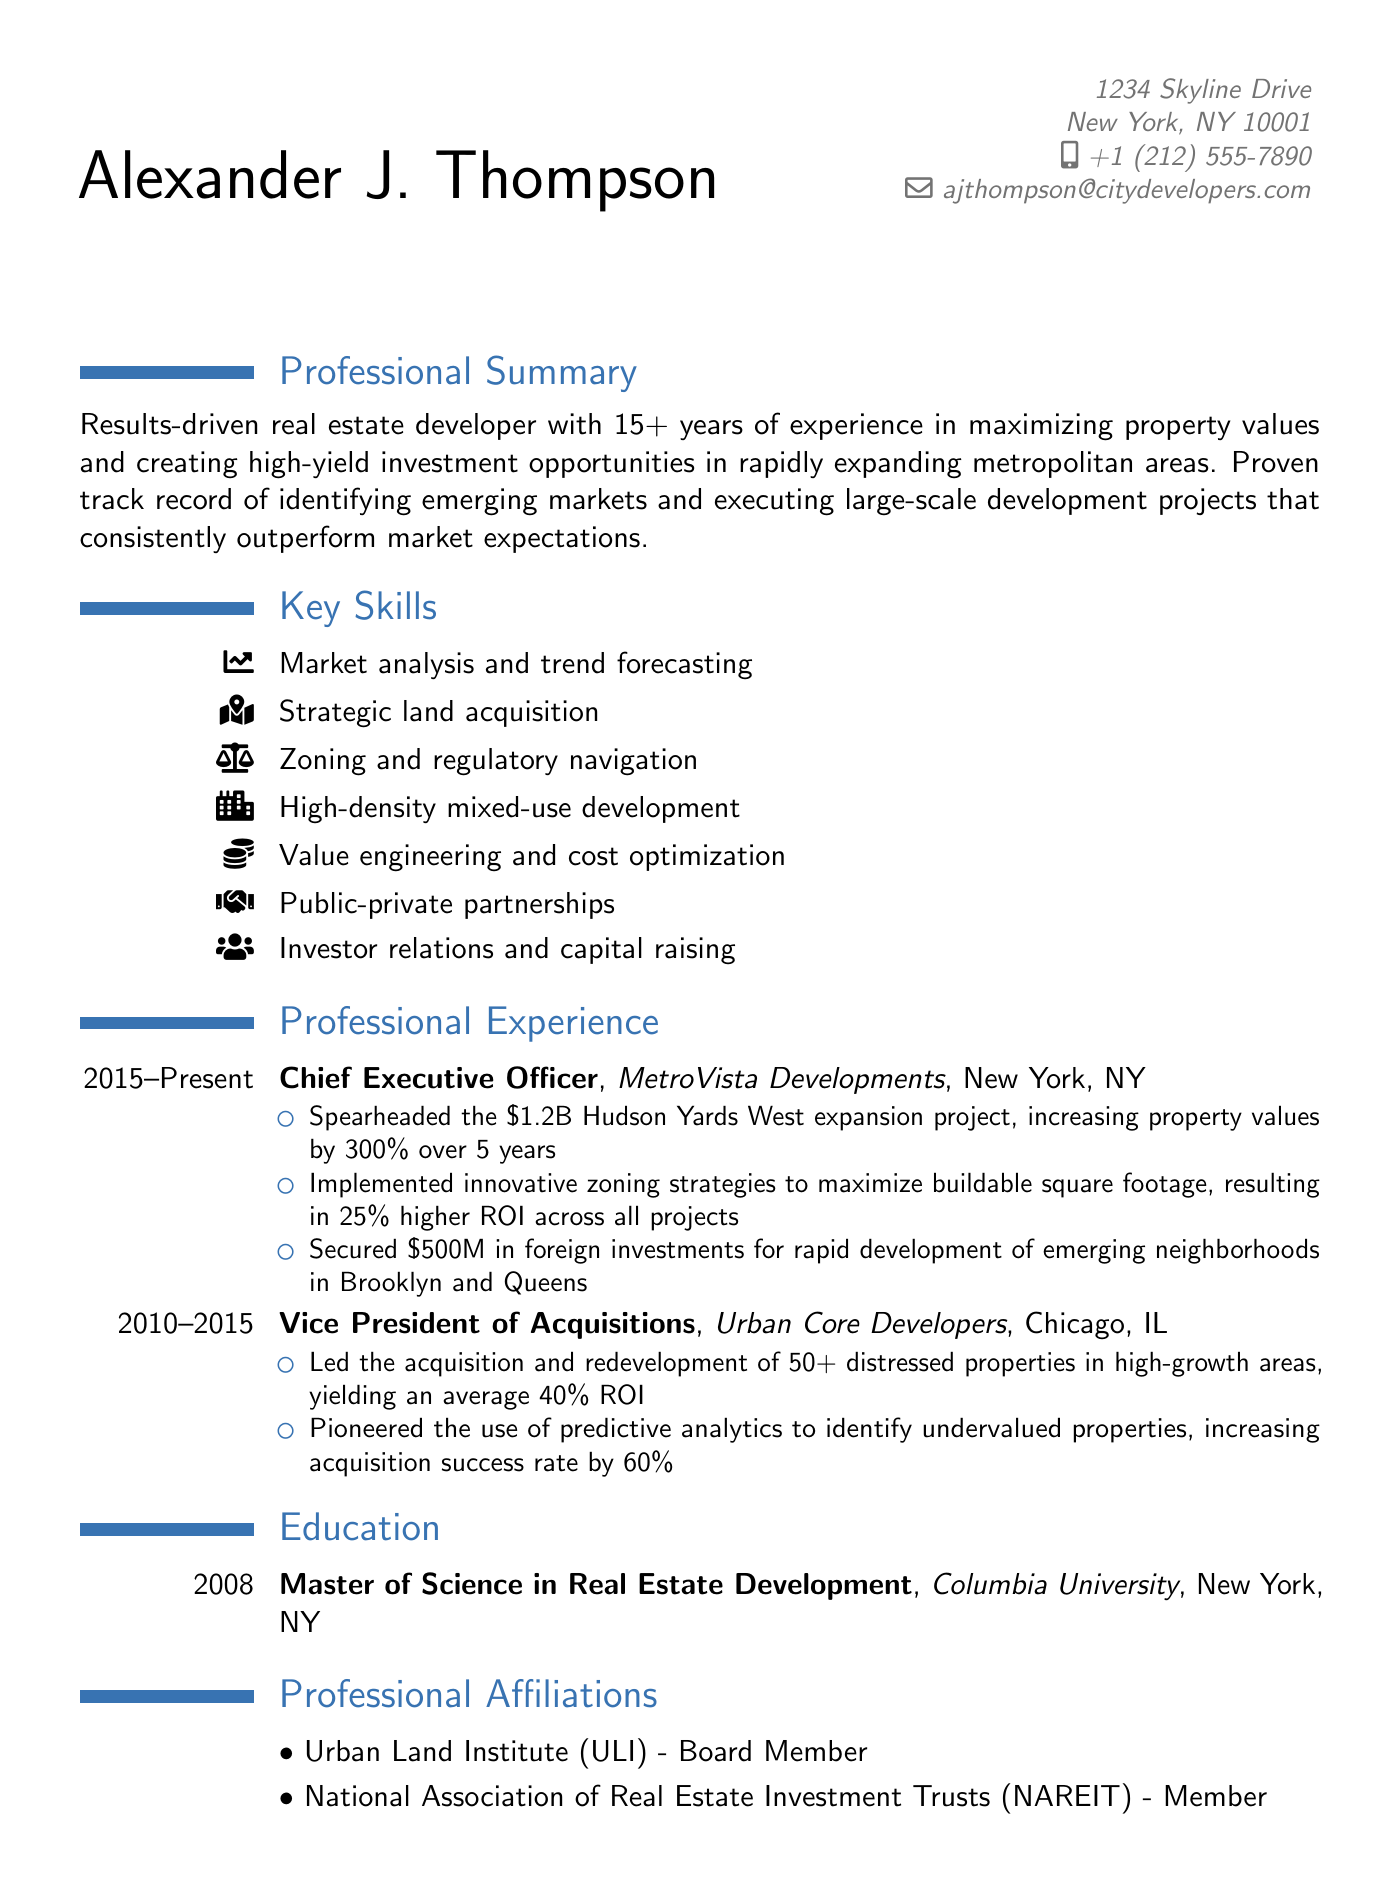What is the name of the CEO? The CEO's name is mentioned in the Professional Experience section as Alexander J. Thompson.
Answer: Alexander J. Thompson What company is associated with the Hudson Yards West expansion project? The Hudson Yards West expansion project is linked to MetroVista Developments, where the person is the CEO.
Answer: MetroVista Developments How many years of experience does Alexander J. Thompson have in real estate development? The Professional Summary states that he has 15+ years of experience in real estate development.
Answer: 15+ What degree does Alexander J. Thompson hold? The Education section lists his degree as Master of Science in Real Estate Development.
Answer: Master of Science in Real Estate Development What is the location of Columbia University? The Education section specifies the location of Columbia University as New York, NY.
Answer: New York, NY What was the average ROI for distressed properties redeveloped by Urban Core Developers? The Professional Experience section indicates that the average ROI for these properties was 40%.
Answer: 40% Which mixed-use tower is mentioned as a notable project? The Notable Projects section lists The Apex at Long Island City as a mixed-use tower.
Answer: The Apex at Long Island City What is one key skill related to financial management listed in the CV? The Key Skills section lists Value engineering and cost optimization as a financial management skill.
Answer: Value engineering and cost optimization What organization is Alexander J. Thompson a board member of? The Professional Affiliations section indicates that he is a board member of the Urban Land Institute (ULI).
Answer: Urban Land Institute (ULI) 